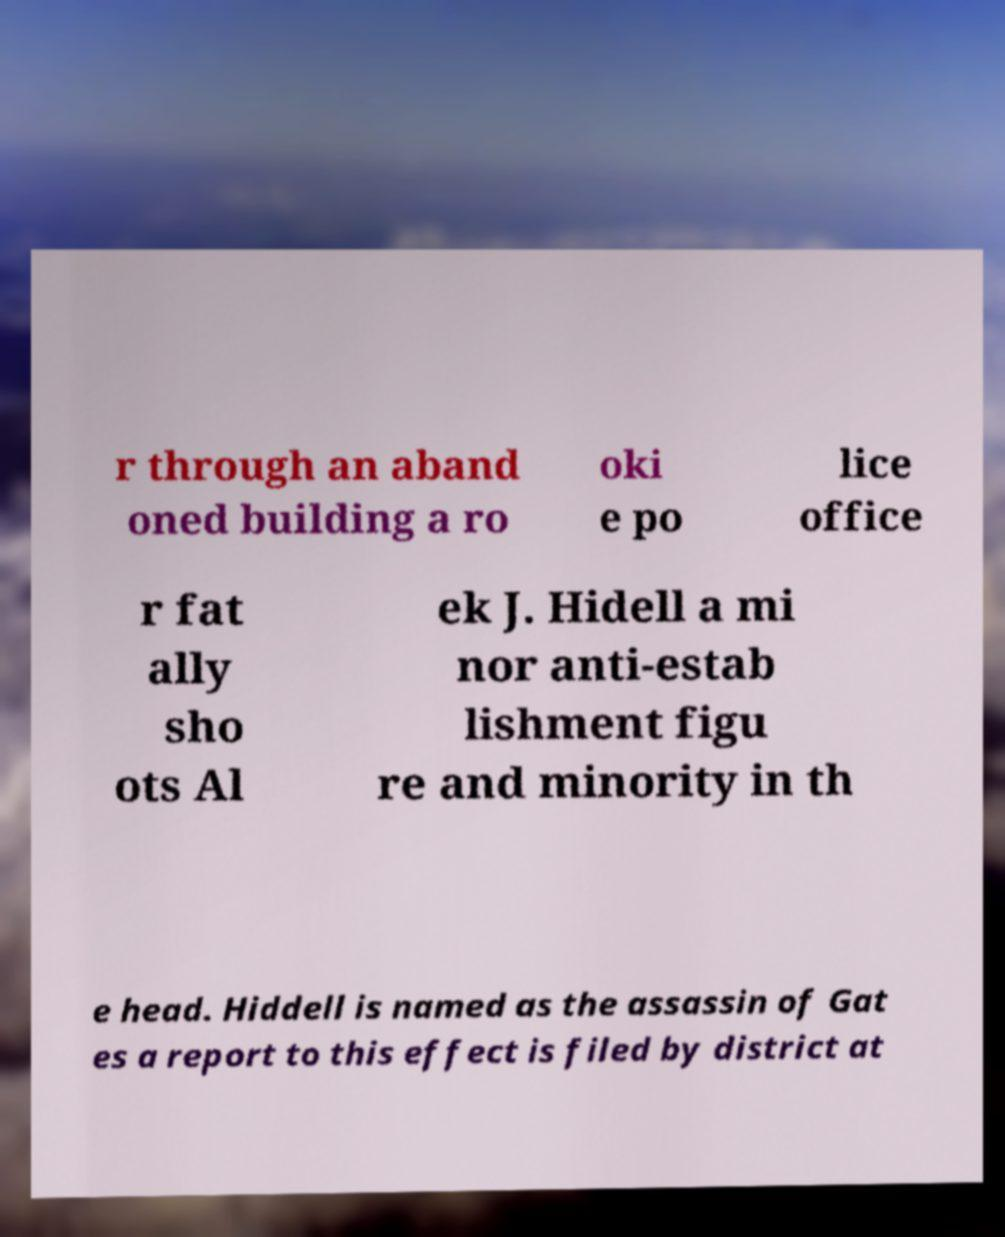What messages or text are displayed in this image? I need them in a readable, typed format. r through an aband oned building a ro oki e po lice office r fat ally sho ots Al ek J. Hidell a mi nor anti-estab lishment figu re and minority in th e head. Hiddell is named as the assassin of Gat es a report to this effect is filed by district at 